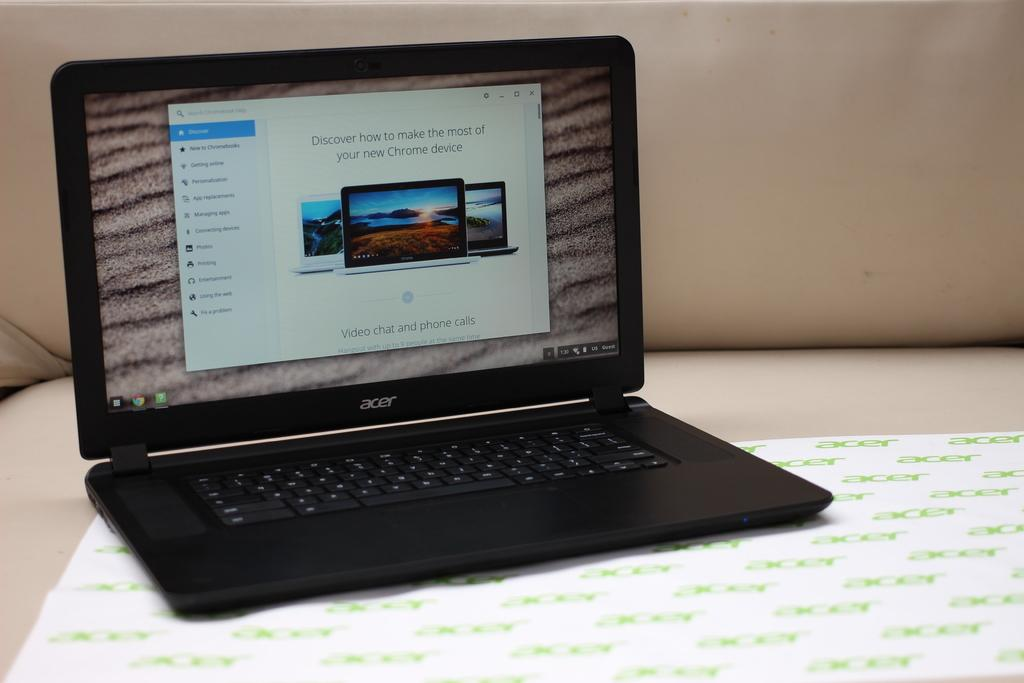What electronic device is visible in the image? There is a laptop in the image. What is the primary feature of the laptop? The laptop has a screen. What is used for typing on the laptop? The laptop has key buttons. What is the paper used for in the image? There is a paper in the image with text on it. What type of bear can be seen sitting on top of the laptop in the image? There is no bear present in the image; it only features a laptop and a paper with text. 